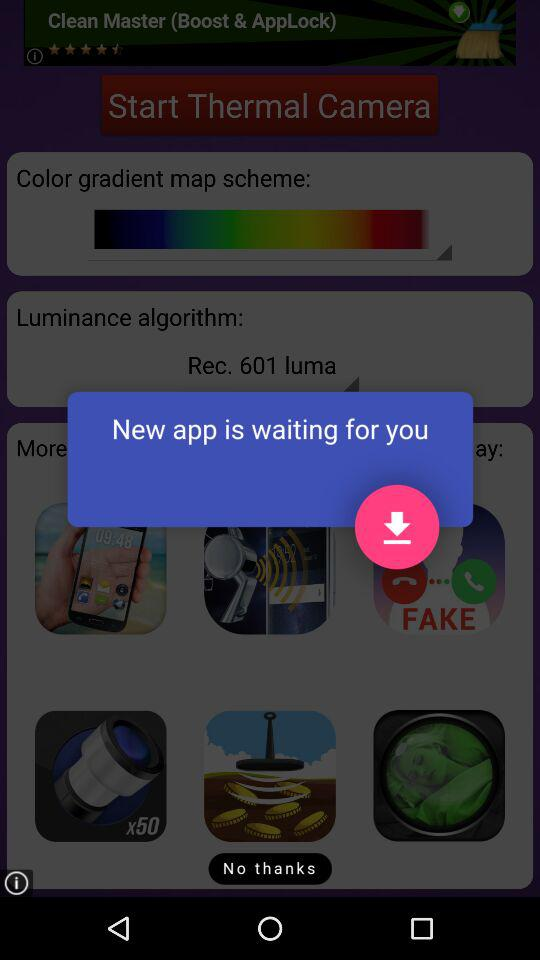What is the selected luminance algorithm? The selected luminance algorithm is "Rec. 601 luma". 